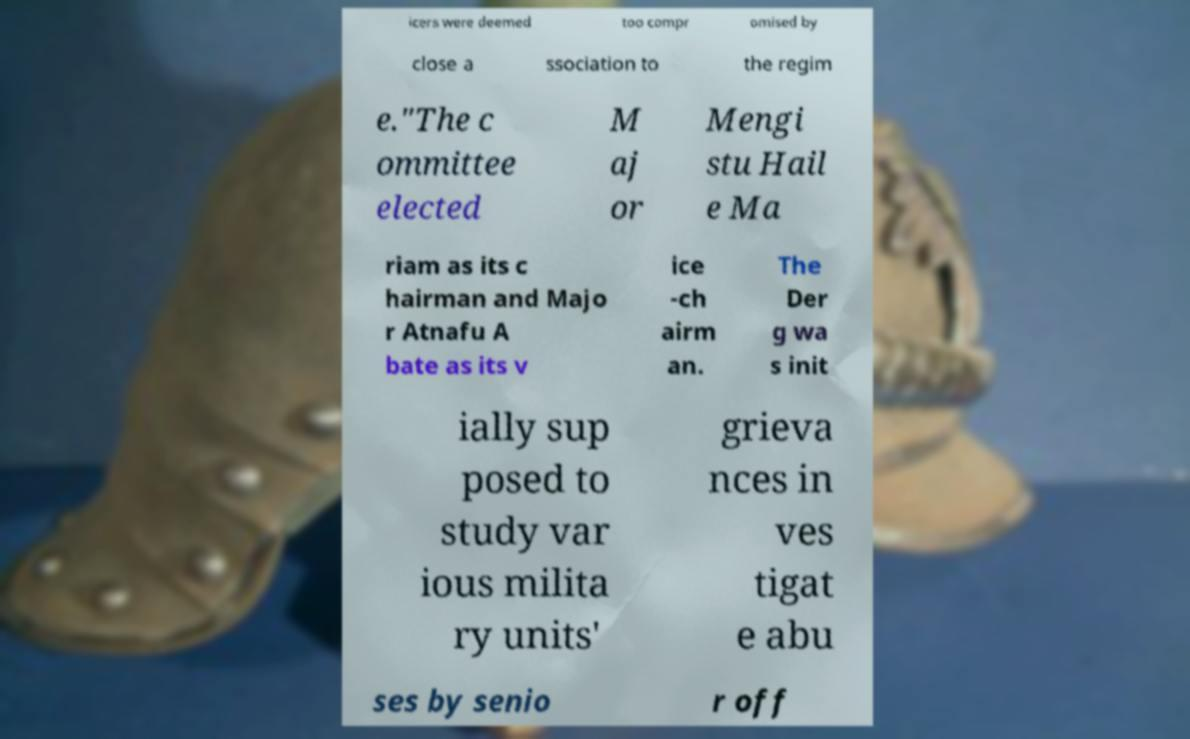Could you assist in decoding the text presented in this image and type it out clearly? icers were deemed too compr omised by close a ssociation to the regim e."The c ommittee elected M aj or Mengi stu Hail e Ma riam as its c hairman and Majo r Atnafu A bate as its v ice -ch airm an. The Der g wa s init ially sup posed to study var ious milita ry units' grieva nces in ves tigat e abu ses by senio r off 